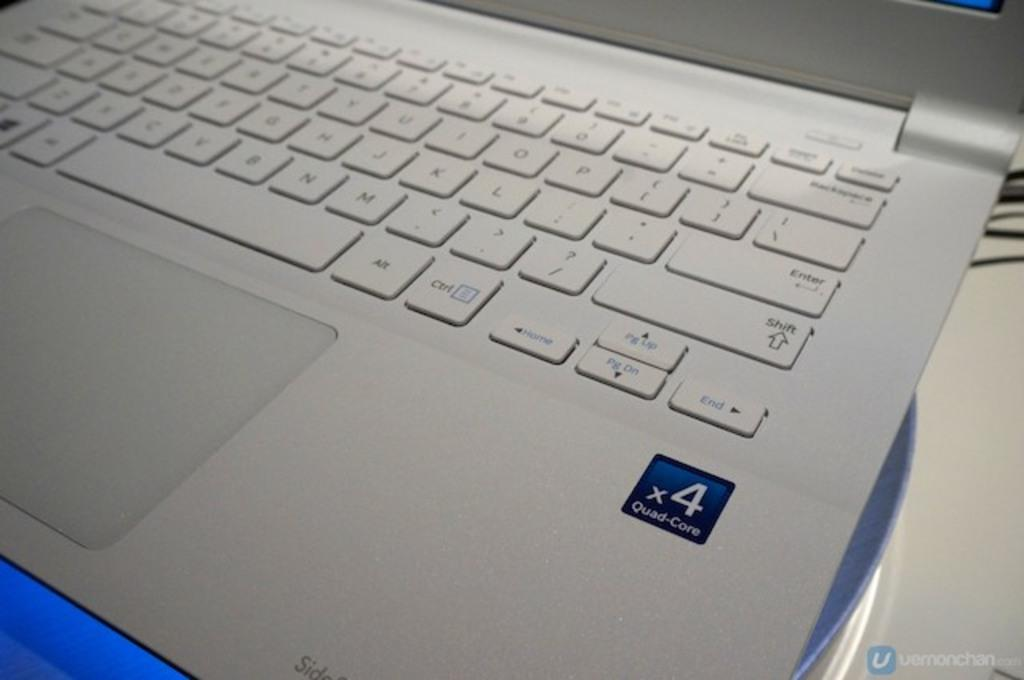<image>
Summarize the visual content of the image. A white laptop that has a quad core processor. 